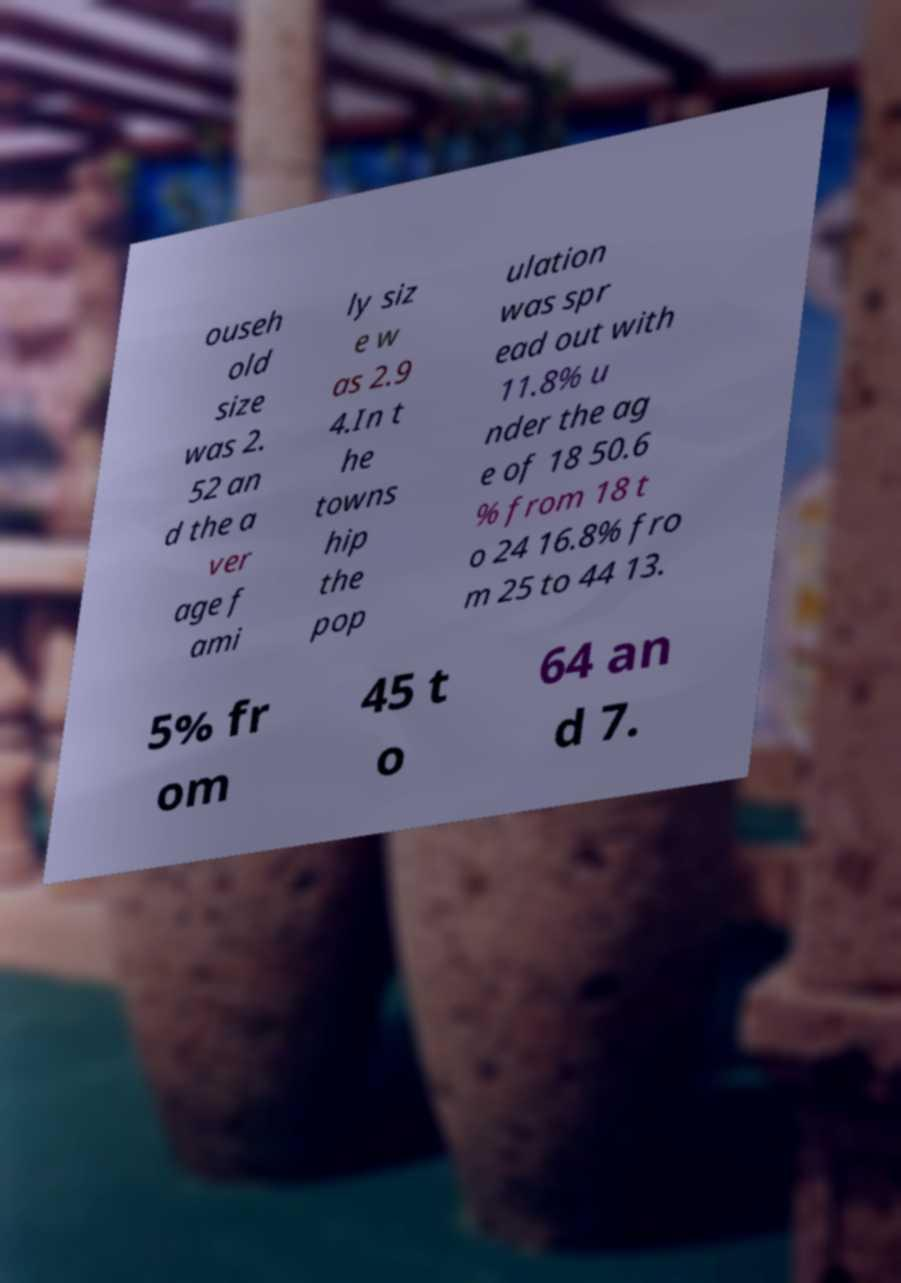Can you read and provide the text displayed in the image?This photo seems to have some interesting text. Can you extract and type it out for me? ouseh old size was 2. 52 an d the a ver age f ami ly siz e w as 2.9 4.In t he towns hip the pop ulation was spr ead out with 11.8% u nder the ag e of 18 50.6 % from 18 t o 24 16.8% fro m 25 to 44 13. 5% fr om 45 t o 64 an d 7. 